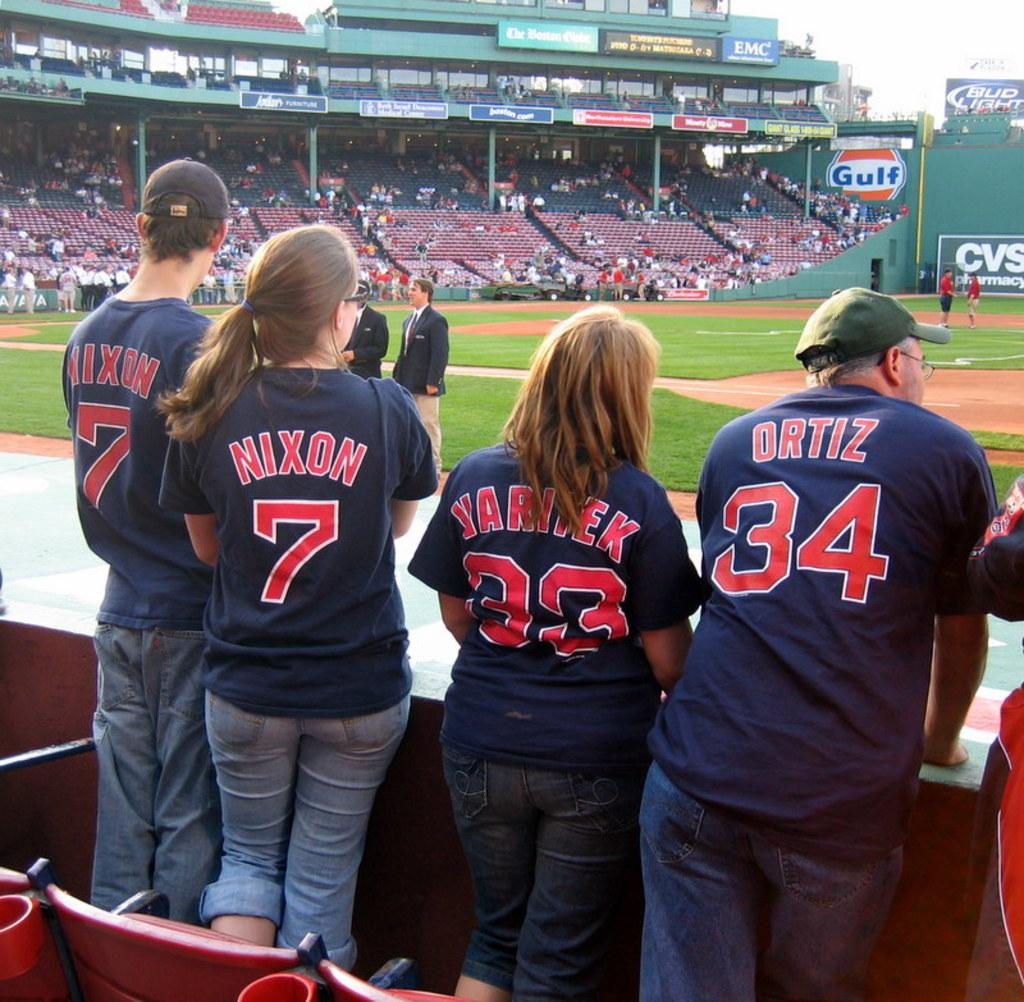<image>
Render a clear and concise summary of the photo. Four people wear shirts with numbers 7, 7, 33 and 34. 